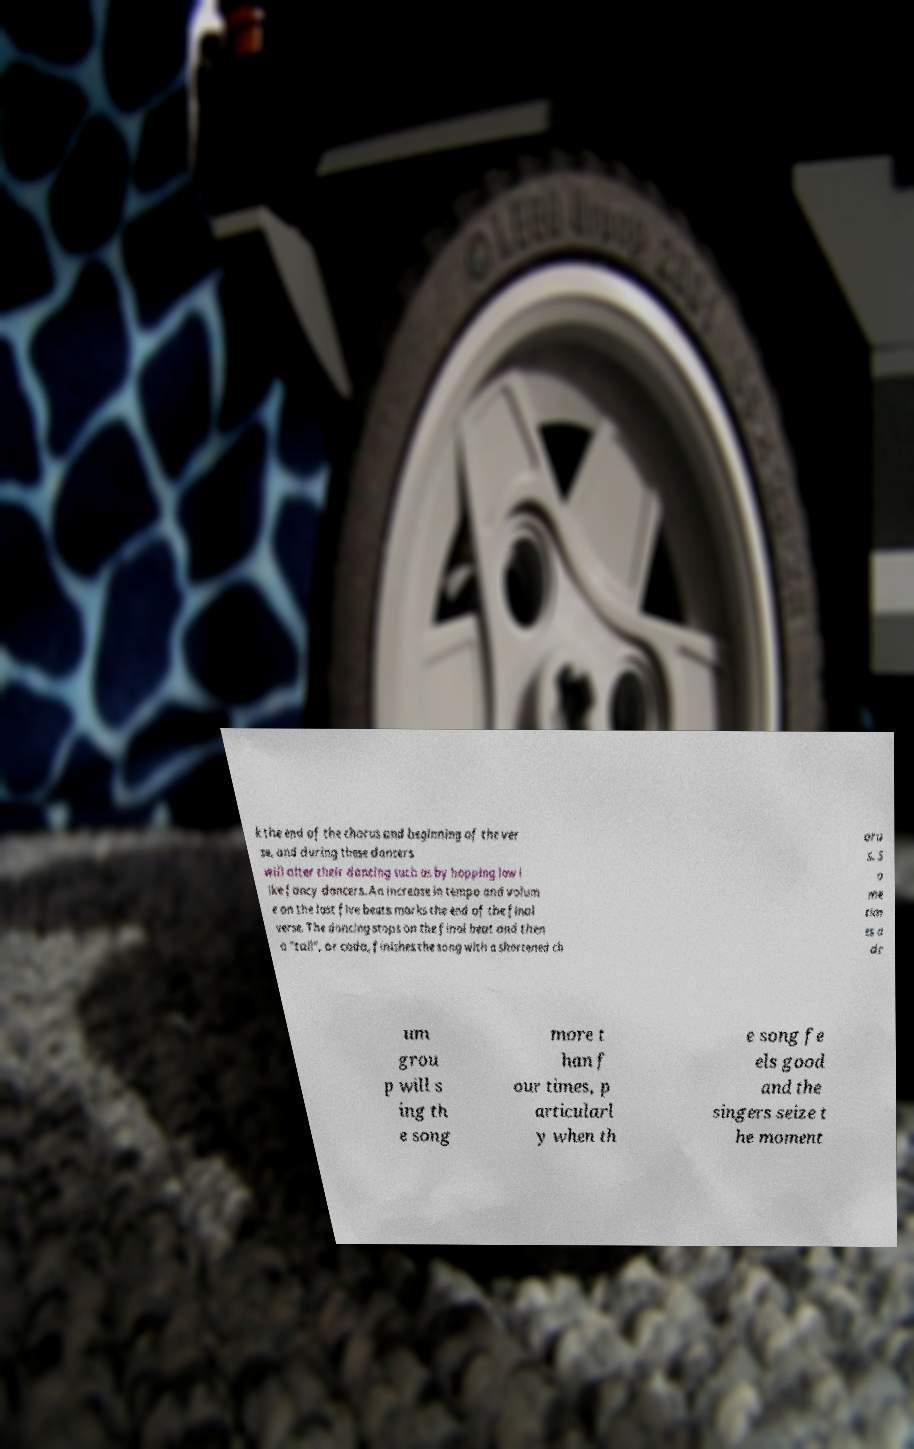Can you read and provide the text displayed in the image?This photo seems to have some interesting text. Can you extract and type it out for me? k the end of the chorus and beginning of the ver se, and during these dancers will alter their dancing such as by hopping low l ike fancy dancers. An increase in tempo and volum e on the last five beats marks the end of the final verse. The dancing stops on the final beat and then a "tail", or coda, finishes the song with a shortened ch oru s. S o me tim es a dr um grou p will s ing th e song more t han f our times, p articularl y when th e song fe els good and the singers seize t he moment 